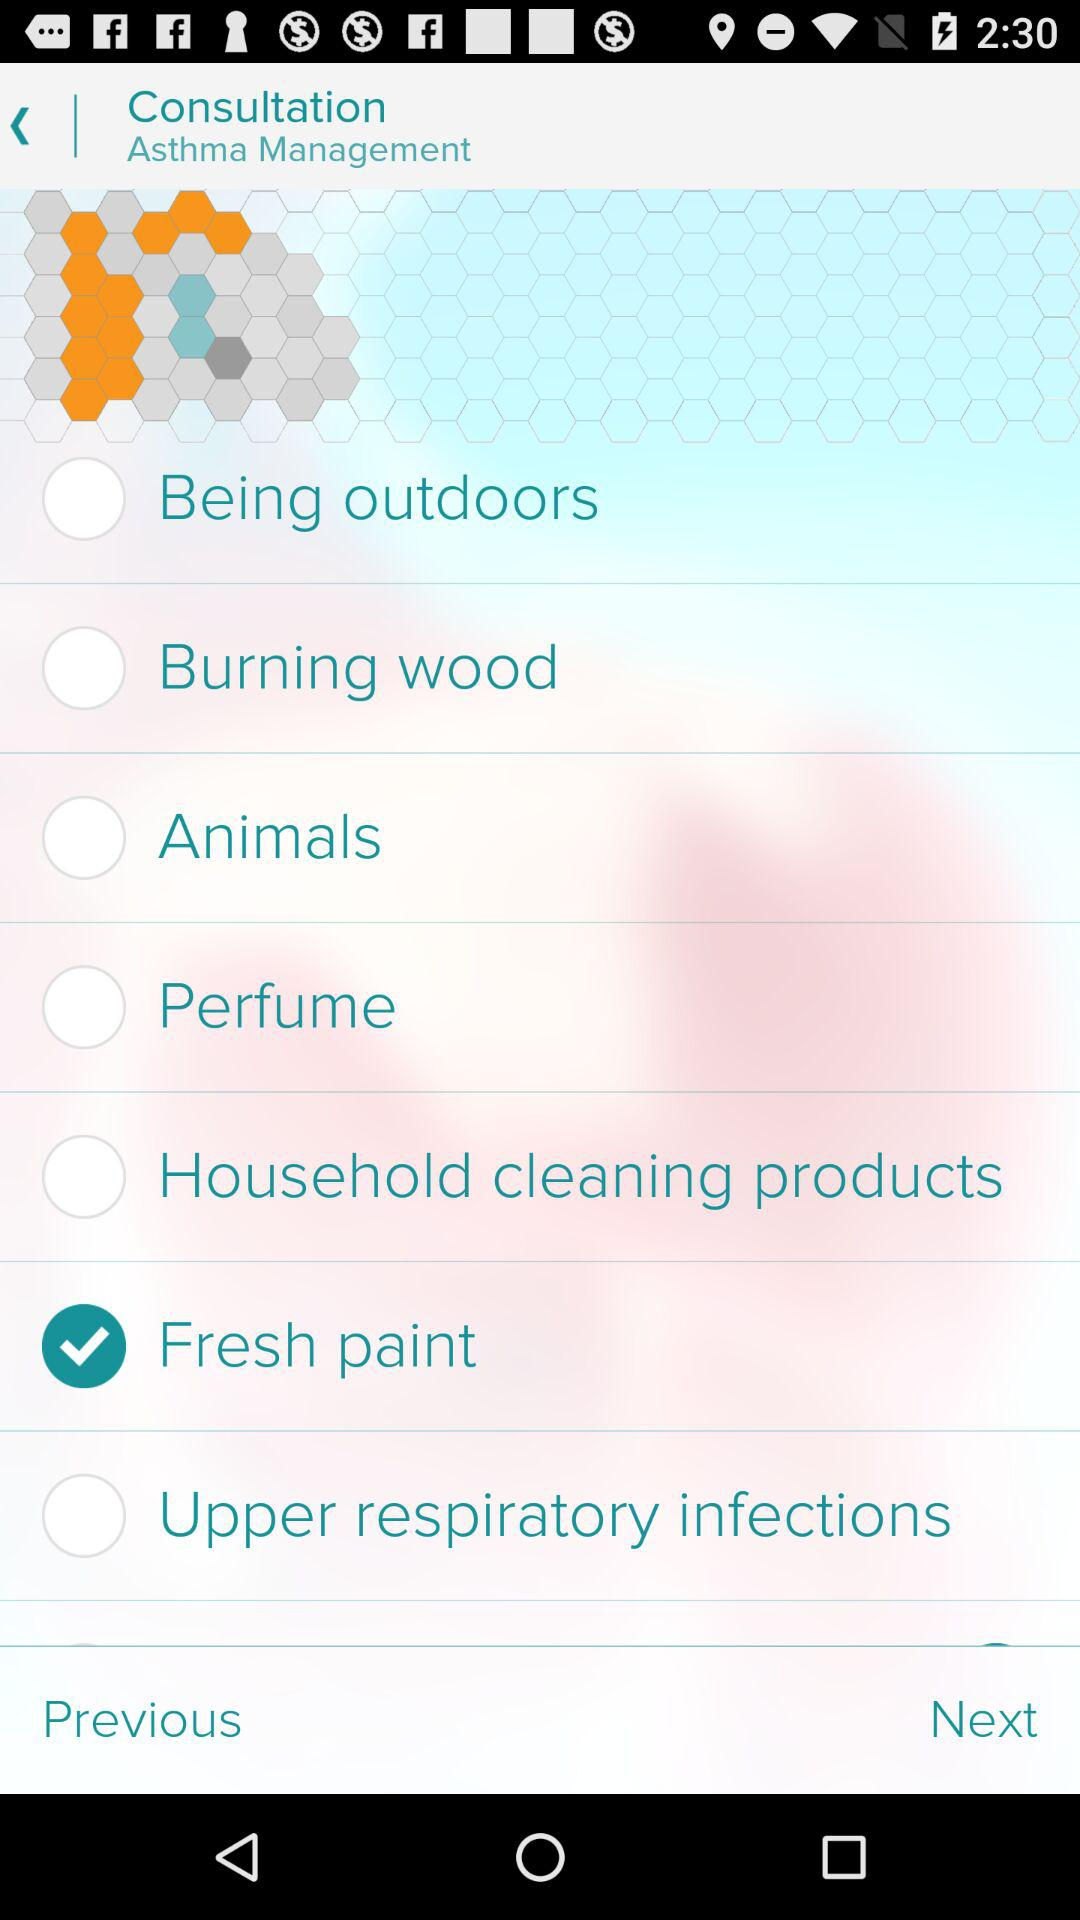How much fresh paint is needed?
When the provided information is insufficient, respond with <no answer>. <no answer> 